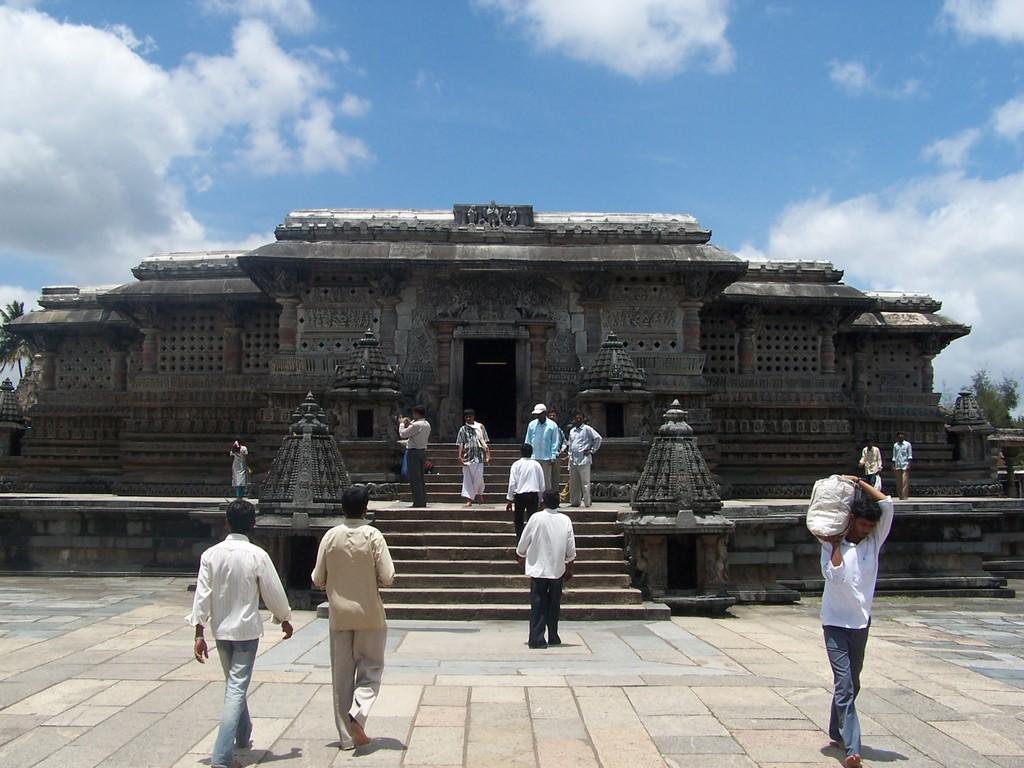What type of structure can be seen in the image? There is a temple in the image. What architectural feature is visible in the image? There are stairs in the image. Who or what is present in the image? There are persons in the image. What type of natural environment is visible in the image? There are trees in the image. What is visible in the sky in the image? The sky is visible in the image, and clouds are present. Can you describe the earthquake happening in the image? There is no earthquake present in the image. What type of bird can be seen flying in the image? There are no birds visible in the image. 